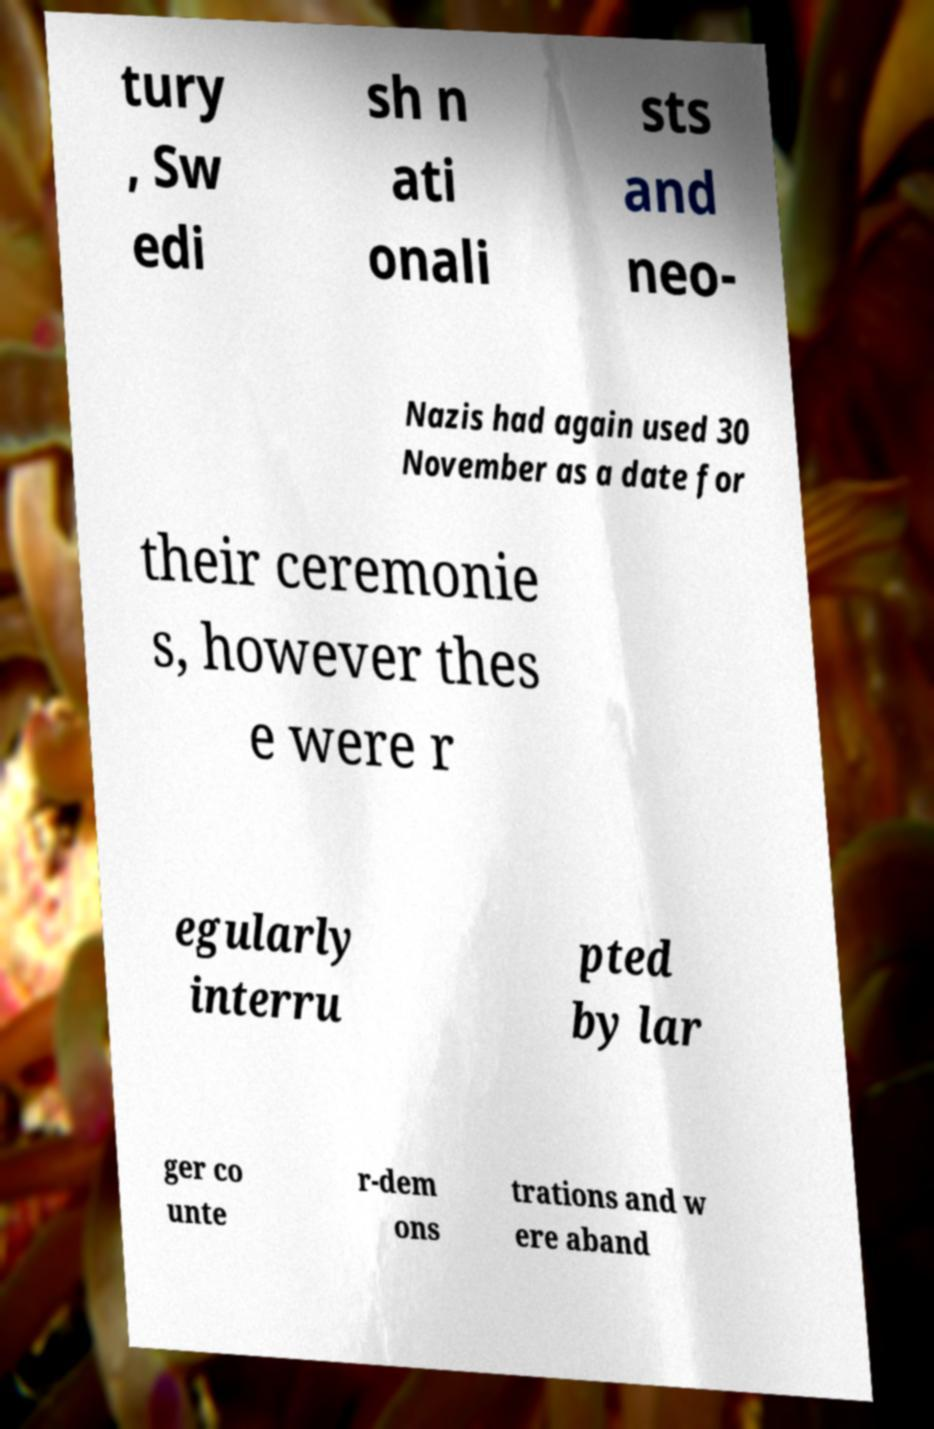Please identify and transcribe the text found in this image. tury , Sw edi sh n ati onali sts and neo- Nazis had again used 30 November as a date for their ceremonie s, however thes e were r egularly interru pted by lar ger co unte r-dem ons trations and w ere aband 